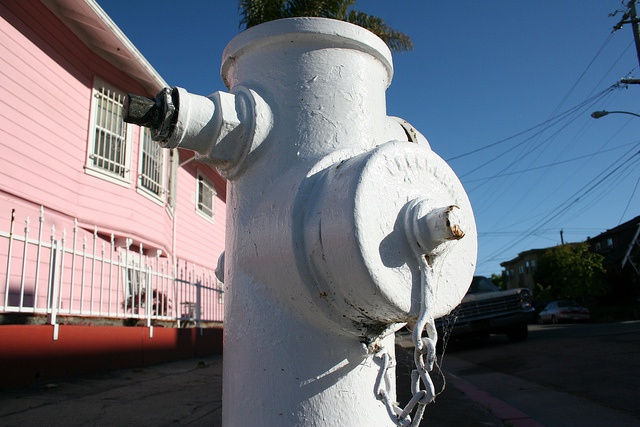Describe the objects in this image and their specific colors. I can see fire hydrant in black, gray, lightgray, and darkgray tones, car in black, blue, darkblue, and gray tones, and car in black, navy, and darkblue tones in this image. 